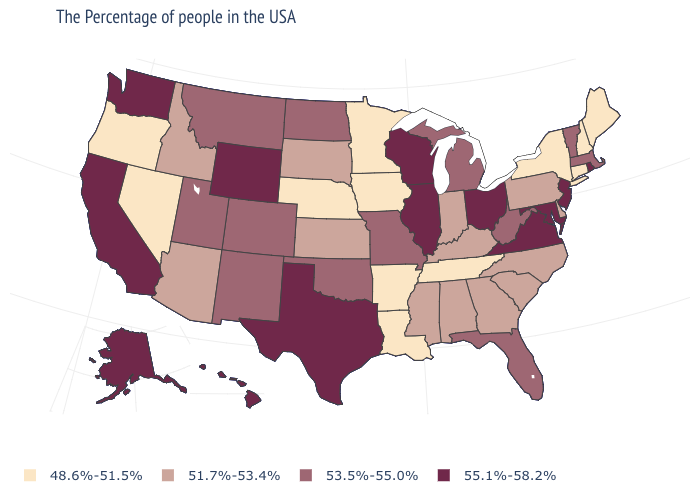Is the legend a continuous bar?
Write a very short answer. No. What is the value of Ohio?
Short answer required. 55.1%-58.2%. What is the lowest value in states that border Oregon?
Be succinct. 48.6%-51.5%. What is the value of Delaware?
Concise answer only. 51.7%-53.4%. What is the value of New York?
Be succinct. 48.6%-51.5%. What is the value of Iowa?
Short answer required. 48.6%-51.5%. Is the legend a continuous bar?
Concise answer only. No. What is the highest value in the South ?
Short answer required. 55.1%-58.2%. What is the lowest value in the USA?
Quick response, please. 48.6%-51.5%. Name the states that have a value in the range 48.6%-51.5%?
Concise answer only. Maine, New Hampshire, Connecticut, New York, Tennessee, Louisiana, Arkansas, Minnesota, Iowa, Nebraska, Nevada, Oregon. Does the first symbol in the legend represent the smallest category?
Write a very short answer. Yes. Name the states that have a value in the range 48.6%-51.5%?
Short answer required. Maine, New Hampshire, Connecticut, New York, Tennessee, Louisiana, Arkansas, Minnesota, Iowa, Nebraska, Nevada, Oregon. What is the value of New Jersey?
Write a very short answer. 55.1%-58.2%. Among the states that border California , which have the lowest value?
Concise answer only. Nevada, Oregon. 